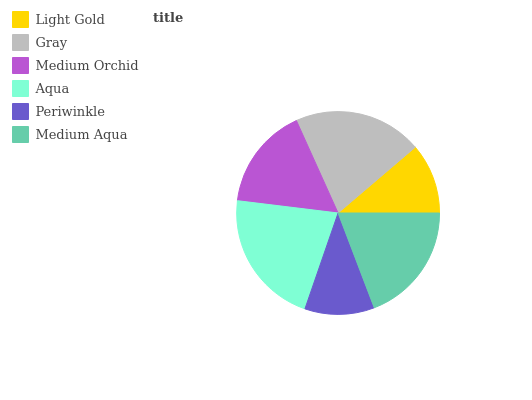Is Periwinkle the minimum?
Answer yes or no. Yes. Is Aqua the maximum?
Answer yes or no. Yes. Is Gray the minimum?
Answer yes or no. No. Is Gray the maximum?
Answer yes or no. No. Is Gray greater than Light Gold?
Answer yes or no. Yes. Is Light Gold less than Gray?
Answer yes or no. Yes. Is Light Gold greater than Gray?
Answer yes or no. No. Is Gray less than Light Gold?
Answer yes or no. No. Is Medium Aqua the high median?
Answer yes or no. Yes. Is Medium Orchid the low median?
Answer yes or no. Yes. Is Periwinkle the high median?
Answer yes or no. No. Is Aqua the low median?
Answer yes or no. No. 